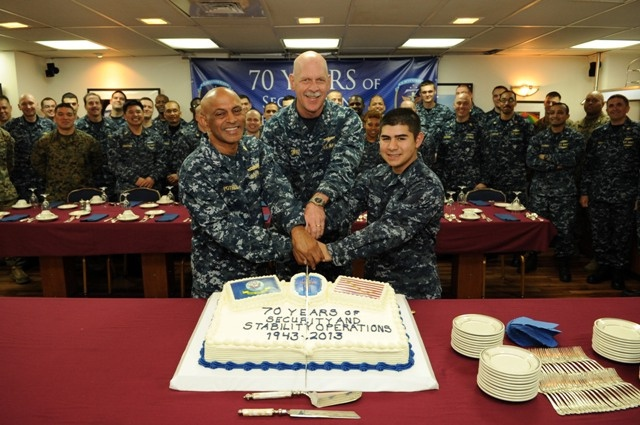Describe the objects in this image and their specific colors. I can see dining table in gray, brown, maroon, black, and beige tones, dining table in maroon, black, brown, and khaki tones, people in gray, black, brown, and darkgray tones, people in maroon, black, olive, and tan tones, and people in gray, black, and maroon tones in this image. 